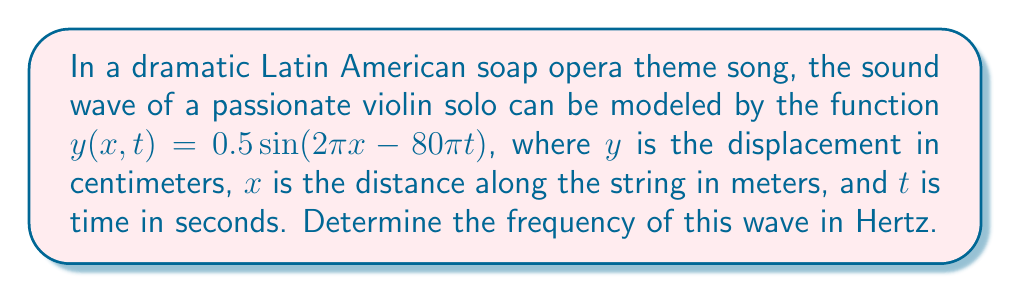Show me your answer to this math problem. To find the frequency of the wave, we need to analyze the given wave equation:

1) The general form of a wave equation is:
   $y(x,t) = A \sin(kx - \omega t)$

   Where:
   $A$ is the amplitude
   $k$ is the wave number
   $\omega$ is the angular frequency

2) Comparing our equation to the general form:
   $y(x,t) = 0.5 \sin(2\pi x - 80\pi t)$

   We can identify:
   $A = 0.5$ cm
   $k = 2\pi$ m^(-1)
   $\omega = 80\pi$ rad/s

3) The angular frequency $\omega$ is related to the frequency $f$ by:
   $\omega = 2\pi f$

4) Substituting our value for $\omega$:
   $80\pi = 2\pi f$

5) Solving for $f$:
   $f = \frac{80\pi}{2\pi} = 40$ Hz

Therefore, the frequency of the wave is 40 Hz.
Answer: 40 Hz 